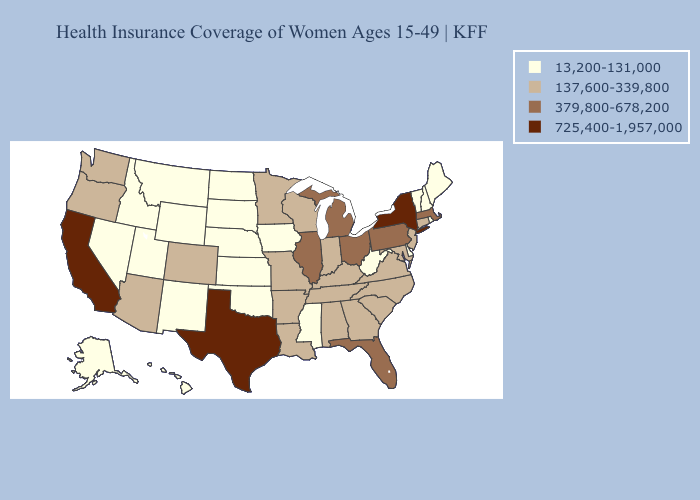What is the lowest value in the USA?
Keep it brief. 13,200-131,000. Among the states that border Oregon , does Nevada have the highest value?
Answer briefly. No. Does California have the highest value in the USA?
Concise answer only. Yes. Does Idaho have the lowest value in the West?
Short answer required. Yes. Does the map have missing data?
Quick response, please. No. Does California have a lower value than Maryland?
Keep it brief. No. What is the value of Missouri?
Be succinct. 137,600-339,800. Which states have the lowest value in the South?
Give a very brief answer. Delaware, Mississippi, Oklahoma, West Virginia. What is the value of Montana?
Concise answer only. 13,200-131,000. Does Kansas have the highest value in the MidWest?
Be succinct. No. What is the value of Montana?
Short answer required. 13,200-131,000. Among the states that border Oklahoma , does Texas have the highest value?
Write a very short answer. Yes. Name the states that have a value in the range 13,200-131,000?
Give a very brief answer. Alaska, Delaware, Hawaii, Idaho, Iowa, Kansas, Maine, Mississippi, Montana, Nebraska, Nevada, New Hampshire, New Mexico, North Dakota, Oklahoma, Rhode Island, South Dakota, Utah, Vermont, West Virginia, Wyoming. Which states have the lowest value in the USA?
Answer briefly. Alaska, Delaware, Hawaii, Idaho, Iowa, Kansas, Maine, Mississippi, Montana, Nebraska, Nevada, New Hampshire, New Mexico, North Dakota, Oklahoma, Rhode Island, South Dakota, Utah, Vermont, West Virginia, Wyoming. Name the states that have a value in the range 13,200-131,000?
Quick response, please. Alaska, Delaware, Hawaii, Idaho, Iowa, Kansas, Maine, Mississippi, Montana, Nebraska, Nevada, New Hampshire, New Mexico, North Dakota, Oklahoma, Rhode Island, South Dakota, Utah, Vermont, West Virginia, Wyoming. 